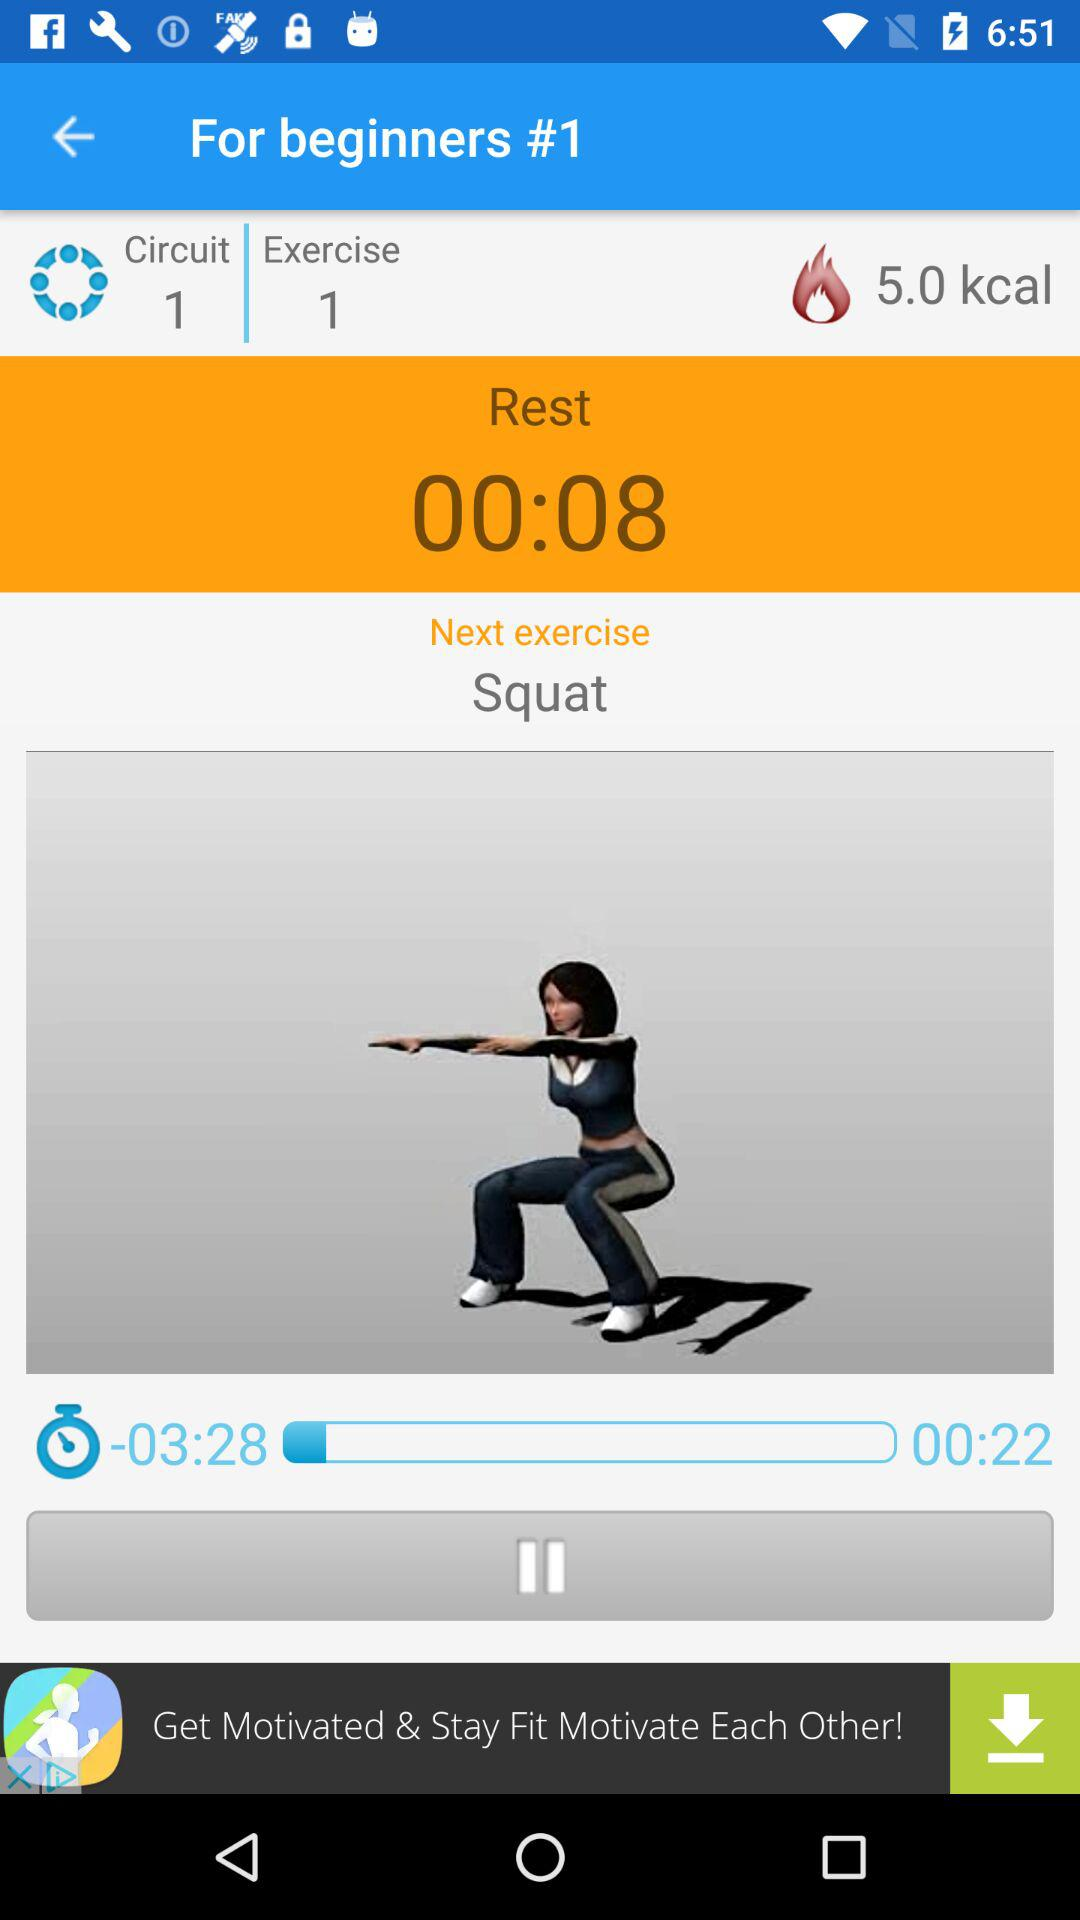What is the time duration left for the exercise? The time duration left is 3 minutes 28 seconds. 